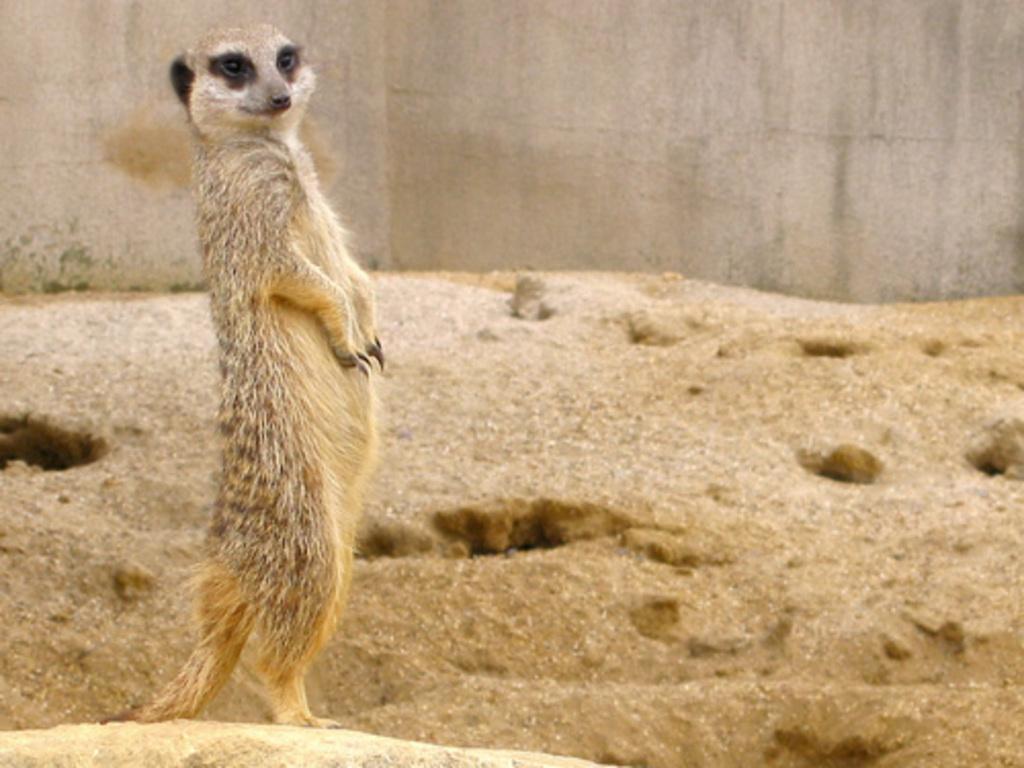Could you give a brief overview of what you see in this image? In this image we can see there is an animal standing on the ground. And at the back there is a wall. 